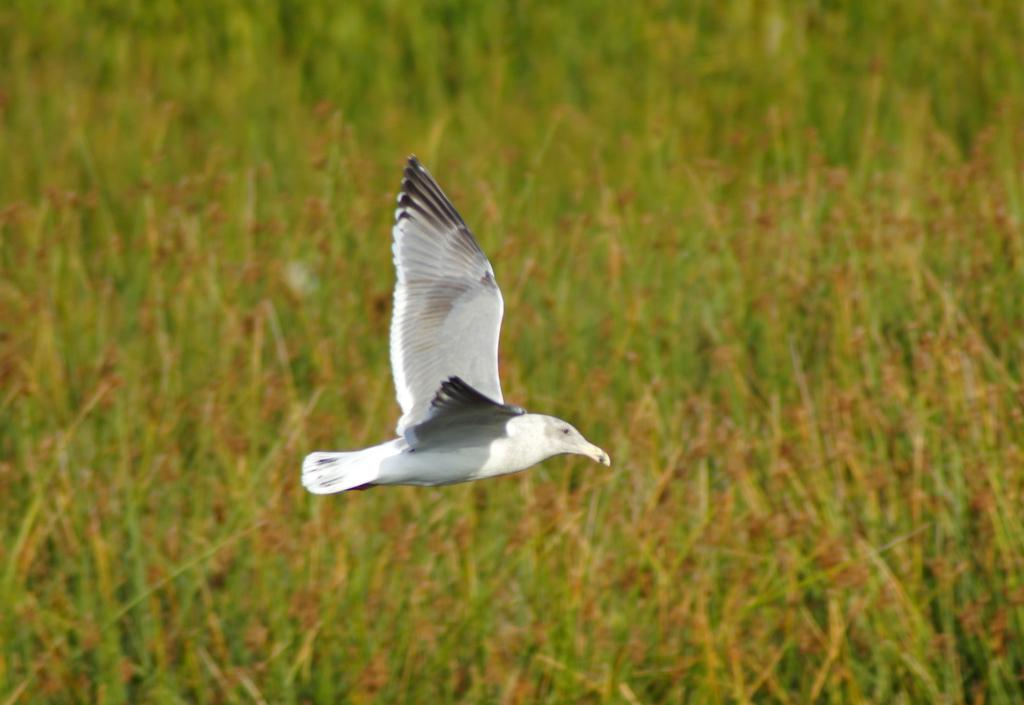What is the main subject of the image? There is a bird flying in the air in the center of the image. What can be seen in the background of the image? There is grass visible in the background of the image. How many waves can be seen crashing on the coast in the image? There is no coast or waves present in the image; it features a bird flying in the air and grass in the background. 